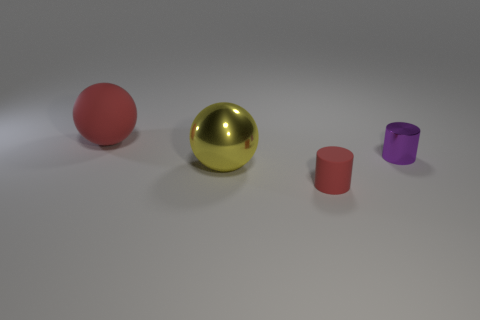Add 1 yellow metal objects. How many objects exist? 5 Subtract 1 red balls. How many objects are left? 3 Subtract all tiny red rubber objects. Subtract all spheres. How many objects are left? 1 Add 4 big red balls. How many big red balls are left? 5 Add 1 tiny purple things. How many tiny purple things exist? 2 